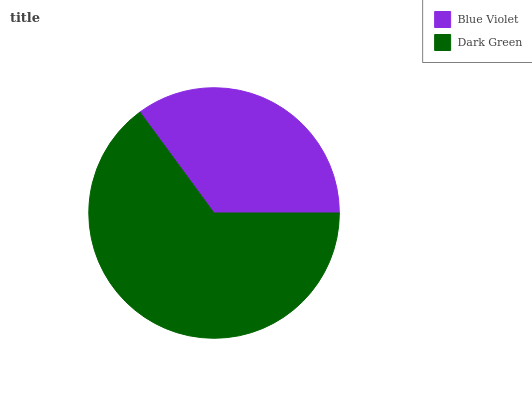Is Blue Violet the minimum?
Answer yes or no. Yes. Is Dark Green the maximum?
Answer yes or no. Yes. Is Dark Green the minimum?
Answer yes or no. No. Is Dark Green greater than Blue Violet?
Answer yes or no. Yes. Is Blue Violet less than Dark Green?
Answer yes or no. Yes. Is Blue Violet greater than Dark Green?
Answer yes or no. No. Is Dark Green less than Blue Violet?
Answer yes or no. No. Is Dark Green the high median?
Answer yes or no. Yes. Is Blue Violet the low median?
Answer yes or no. Yes. Is Blue Violet the high median?
Answer yes or no. No. Is Dark Green the low median?
Answer yes or no. No. 